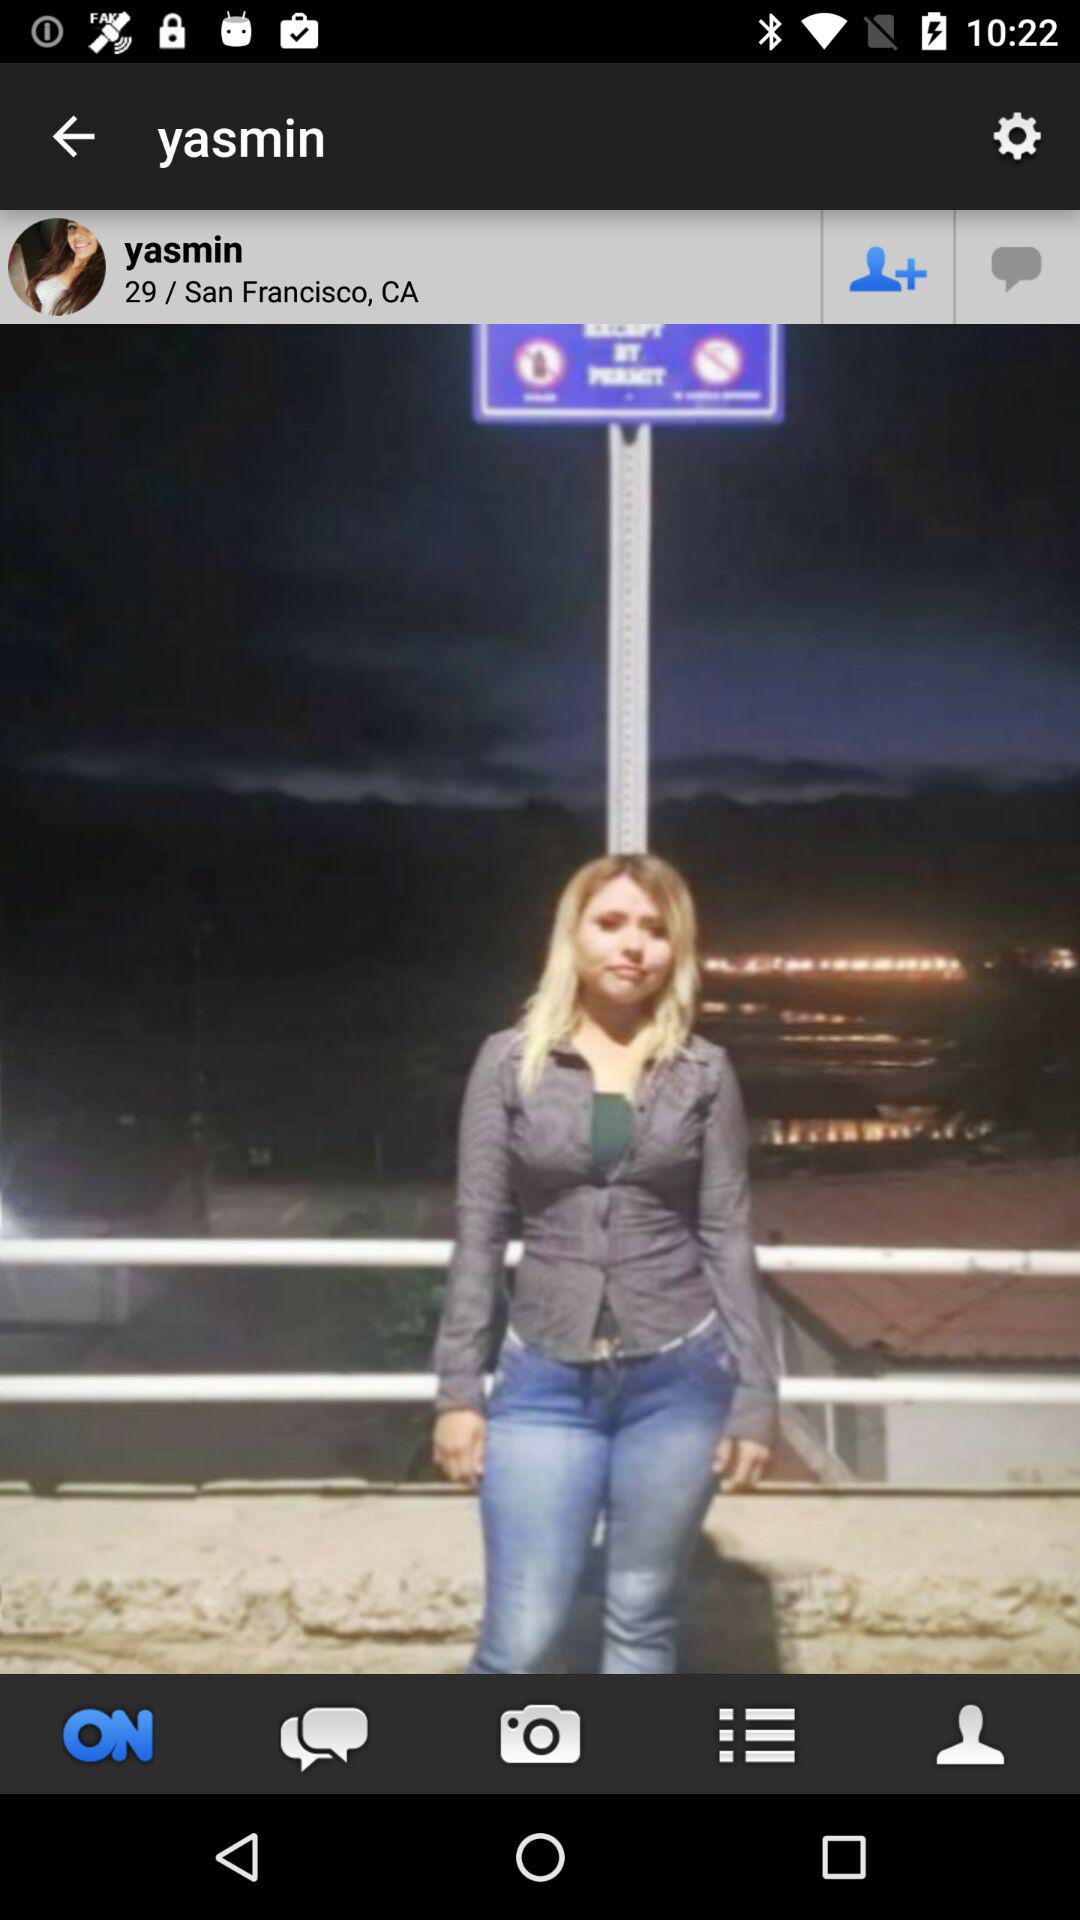What is the username? The username is Yasmin. 